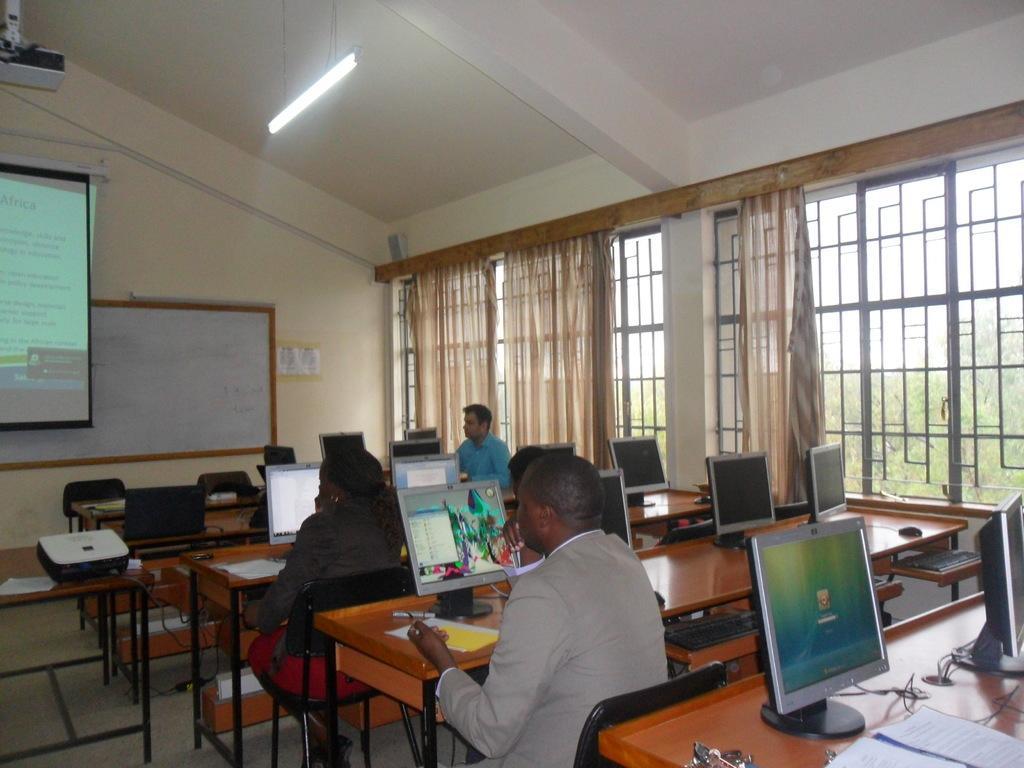In one or two sentences, can you explain what this image depicts? This image is taken inside a room, there are four people in this room, sitting on the chairs and there are many benches and on top of that there are many monitor screens on them. At the bottom of the image there is a floor. In the left side of the image there is a table and on top of that there is a projector. In the background there is a projector screen and a board on the wall and a window with curtains. At the top of the image there is a ceiling with light. 